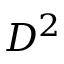Convert formula to latex. <formula><loc_0><loc_0><loc_500><loc_500>D ^ { 2 }</formula> 